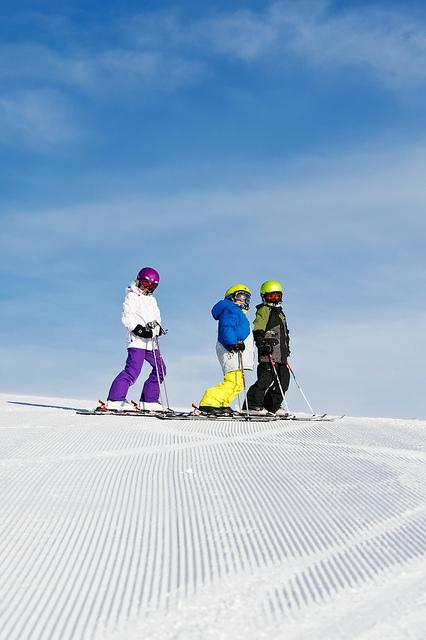Are all of the children wearing helmets?
Concise answer only. Yes. Are there clouds here?
Quick response, please. Yes. What color is the person's pants on the right?
Write a very short answer. Black. How many people are there?
Write a very short answer. 3. Are they in the snow?
Be succinct. Yes. How many people are wearing black pants?
Short answer required. 1. 